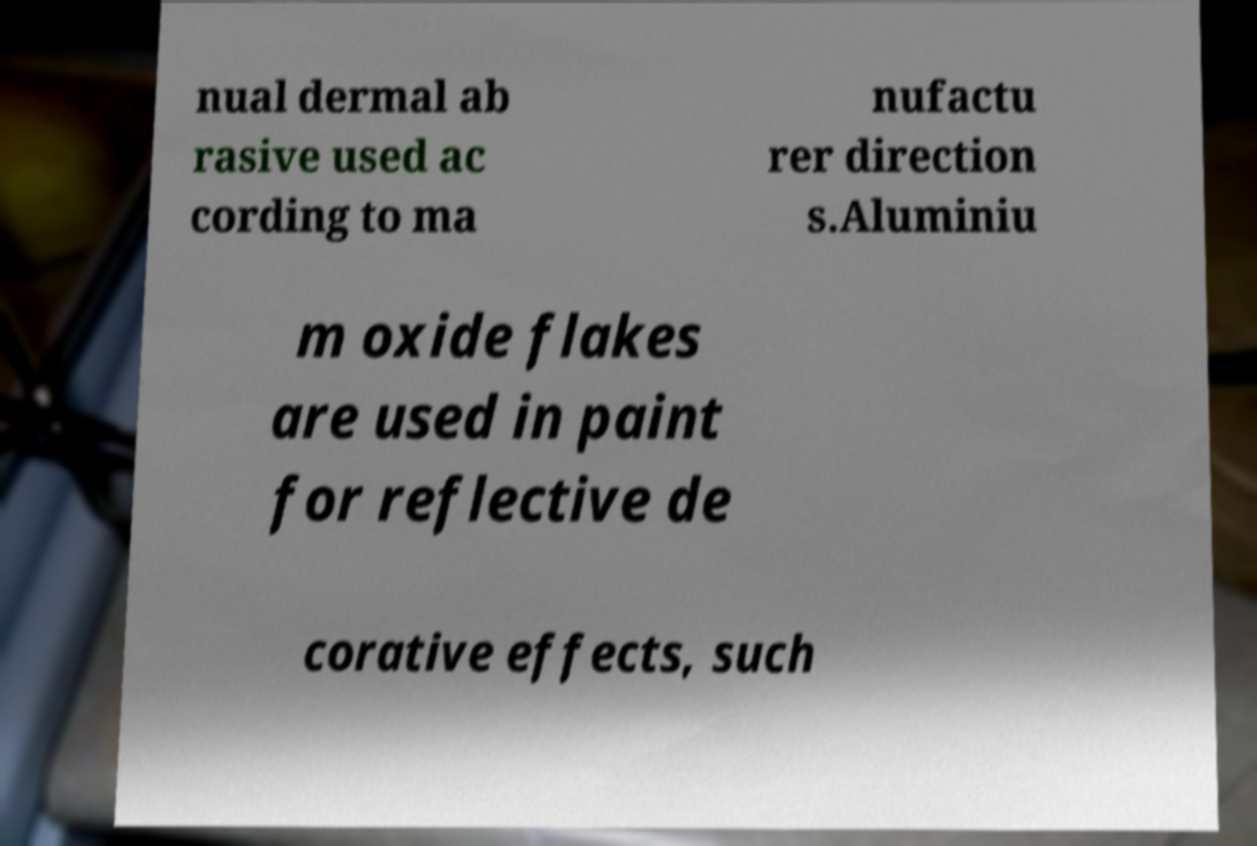There's text embedded in this image that I need extracted. Can you transcribe it verbatim? nual dermal ab rasive used ac cording to ma nufactu rer direction s.Aluminiu m oxide flakes are used in paint for reflective de corative effects, such 